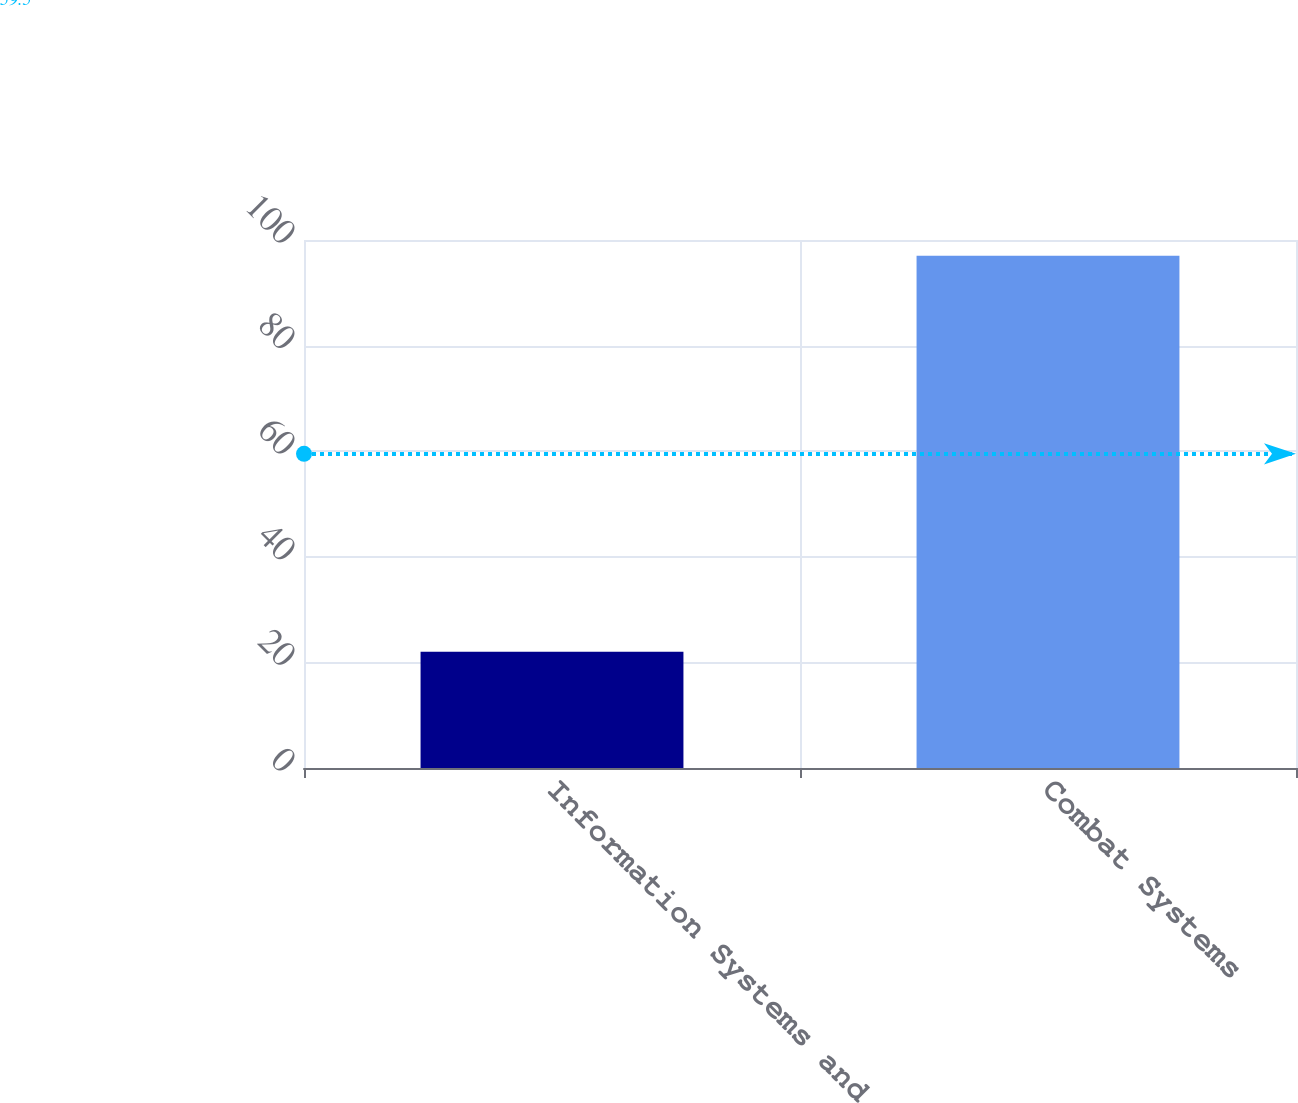Convert chart to OTSL. <chart><loc_0><loc_0><loc_500><loc_500><bar_chart><fcel>Information Systems and<fcel>Combat Systems<nl><fcel>22<fcel>97<nl></chart> 